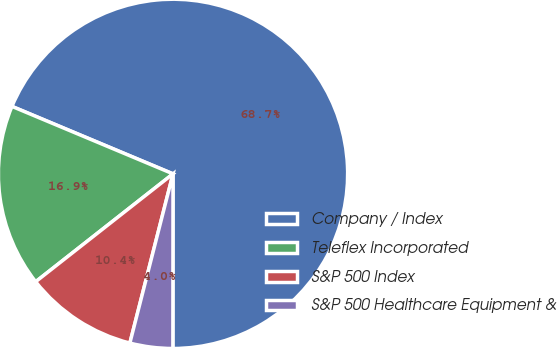Convert chart to OTSL. <chart><loc_0><loc_0><loc_500><loc_500><pie_chart><fcel>Company / Index<fcel>Teleflex Incorporated<fcel>S&P 500 Index<fcel>S&P 500 Healthcare Equipment &<nl><fcel>68.7%<fcel>16.91%<fcel>10.43%<fcel>3.96%<nl></chart> 